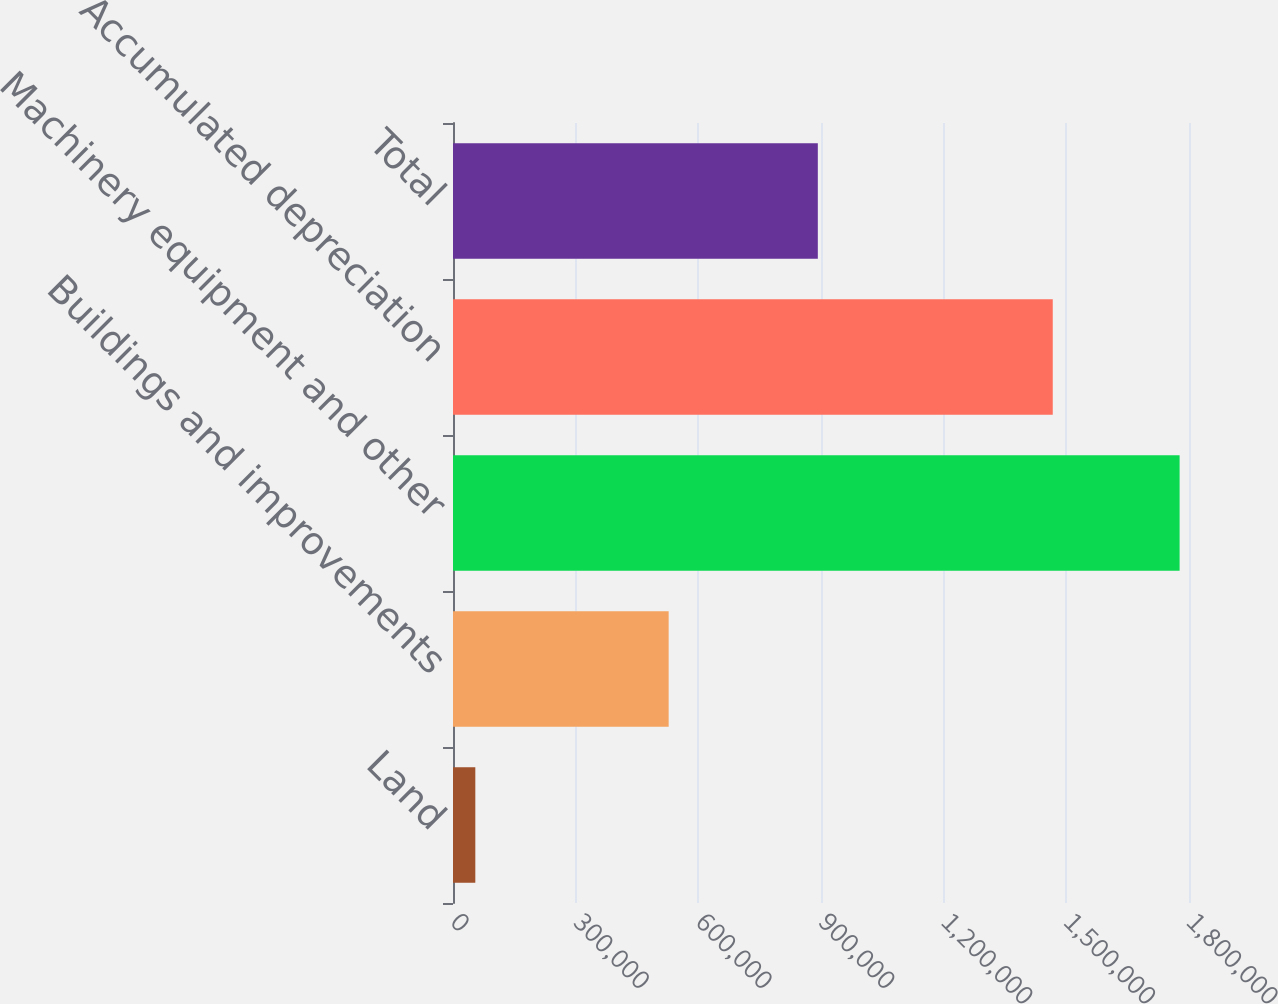Convert chart to OTSL. <chart><loc_0><loc_0><loc_500><loc_500><bar_chart><fcel>Land<fcel>Buildings and improvements<fcel>Machinery equipment and other<fcel>Accumulated depreciation<fcel>Total<nl><fcel>54579<fcel>527429<fcel>1.77703e+06<fcel>1.4668e+06<fcel>892237<nl></chart> 